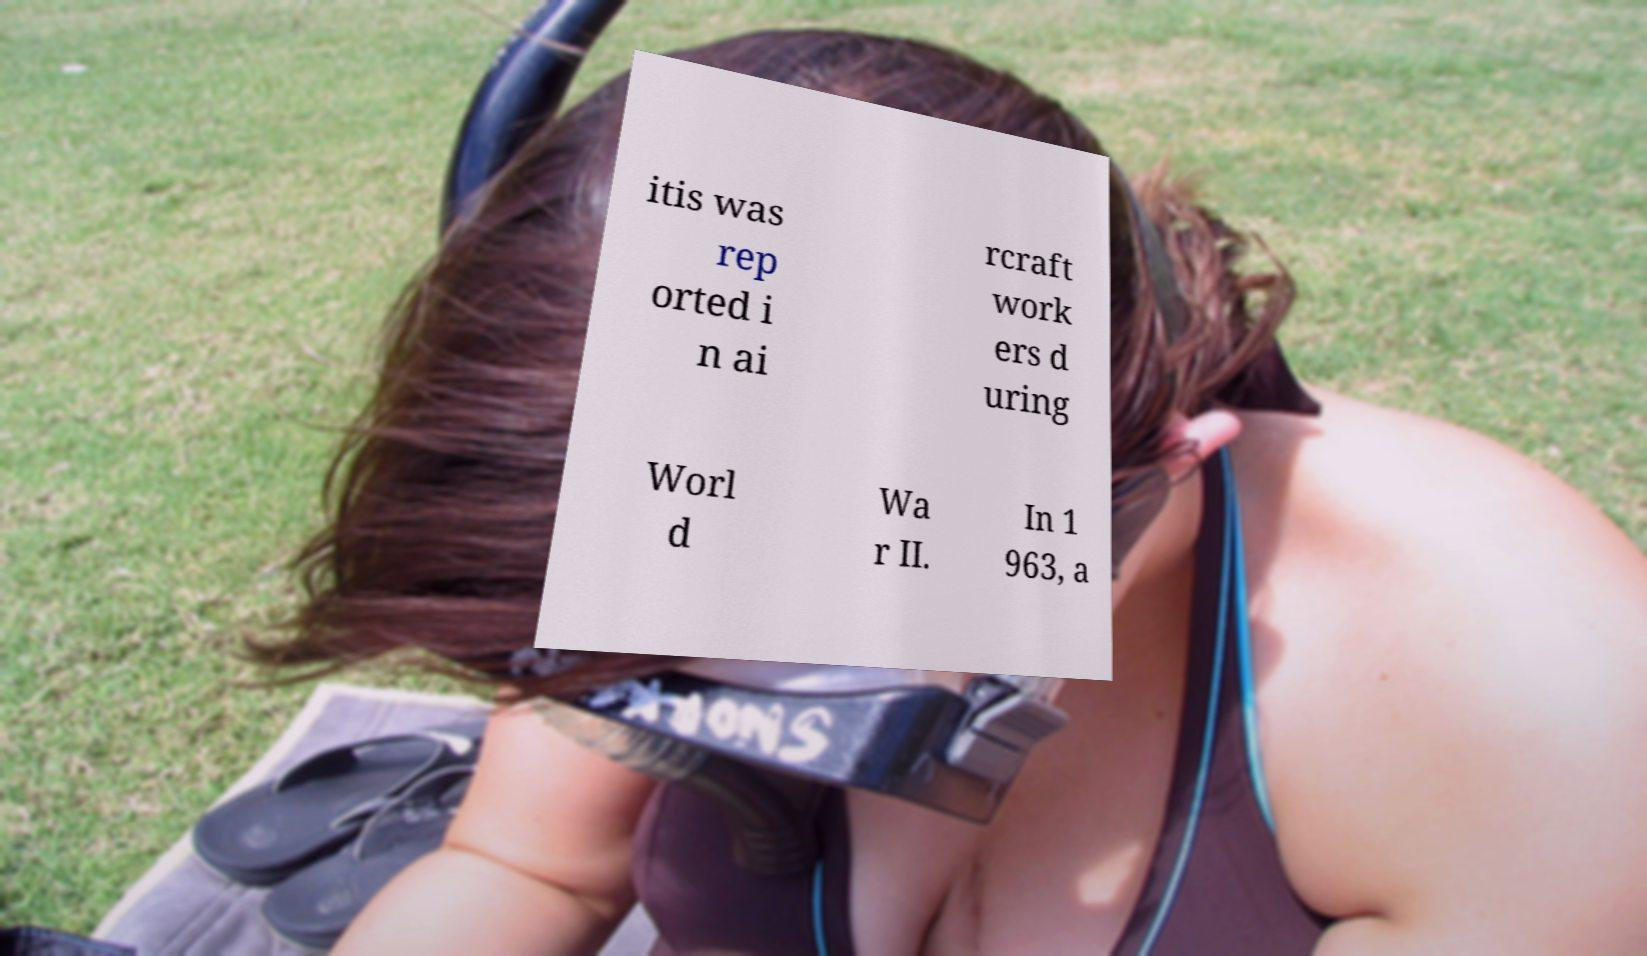Please identify and transcribe the text found in this image. itis was rep orted i n ai rcraft work ers d uring Worl d Wa r II. In 1 963, a 